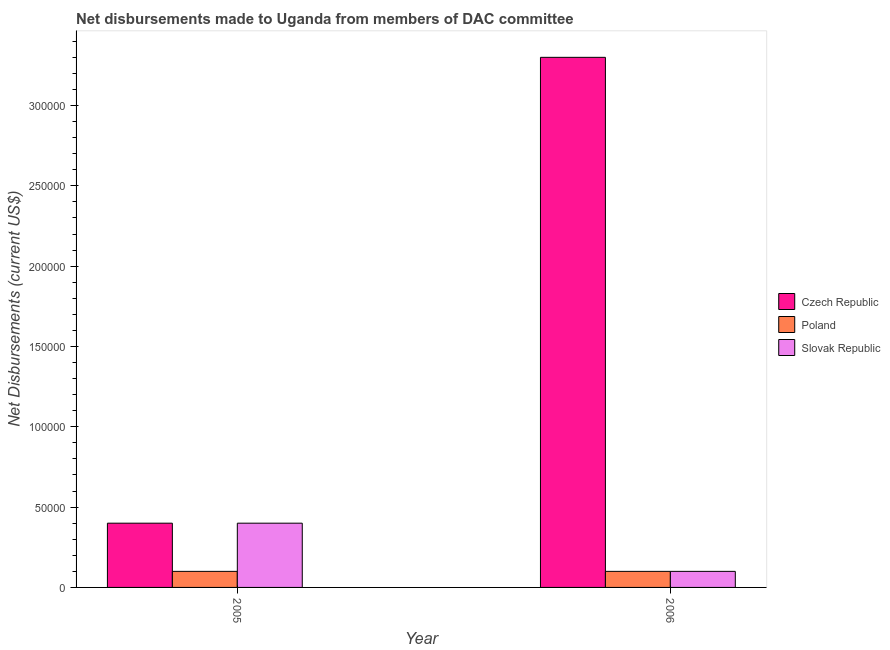How many groups of bars are there?
Ensure brevity in your answer.  2. Are the number of bars per tick equal to the number of legend labels?
Give a very brief answer. Yes. Are the number of bars on each tick of the X-axis equal?
Your answer should be very brief. Yes. How many bars are there on the 1st tick from the left?
Give a very brief answer. 3. What is the net disbursements made by poland in 2006?
Your answer should be compact. 10000. Across all years, what is the maximum net disbursements made by poland?
Your answer should be compact. 10000. Across all years, what is the minimum net disbursements made by slovak republic?
Your answer should be very brief. 10000. In which year was the net disbursements made by poland maximum?
Your response must be concise. 2005. In which year was the net disbursements made by czech republic minimum?
Your response must be concise. 2005. What is the total net disbursements made by czech republic in the graph?
Ensure brevity in your answer.  3.70e+05. What is the difference between the net disbursements made by czech republic in 2005 and that in 2006?
Your answer should be very brief. -2.90e+05. What is the difference between the net disbursements made by slovak republic in 2006 and the net disbursements made by czech republic in 2005?
Your response must be concise. -3.00e+04. What is the average net disbursements made by czech republic per year?
Your answer should be compact. 1.85e+05. What is the ratio of the net disbursements made by slovak republic in 2005 to that in 2006?
Keep it short and to the point. 4. Is the net disbursements made by slovak republic in 2005 less than that in 2006?
Your response must be concise. No. What does the 3rd bar from the left in 2006 represents?
Offer a terse response. Slovak Republic. What does the 1st bar from the right in 2005 represents?
Make the answer very short. Slovak Republic. Is it the case that in every year, the sum of the net disbursements made by czech republic and net disbursements made by poland is greater than the net disbursements made by slovak republic?
Offer a terse response. Yes. How many bars are there?
Offer a very short reply. 6. Are all the bars in the graph horizontal?
Provide a succinct answer. No. What is the difference between two consecutive major ticks on the Y-axis?
Your answer should be compact. 5.00e+04. Does the graph contain any zero values?
Your answer should be compact. No. Where does the legend appear in the graph?
Ensure brevity in your answer.  Center right. How many legend labels are there?
Ensure brevity in your answer.  3. What is the title of the graph?
Keep it short and to the point. Net disbursements made to Uganda from members of DAC committee. Does "Hydroelectric sources" appear as one of the legend labels in the graph?
Give a very brief answer. No. What is the label or title of the X-axis?
Provide a short and direct response. Year. What is the label or title of the Y-axis?
Make the answer very short. Net Disbursements (current US$). What is the Net Disbursements (current US$) in Czech Republic in 2005?
Provide a succinct answer. 4.00e+04. What is the Net Disbursements (current US$) of Poland in 2005?
Offer a terse response. 10000. What is the Net Disbursements (current US$) in Slovak Republic in 2006?
Your answer should be very brief. 10000. Across all years, what is the maximum Net Disbursements (current US$) of Poland?
Provide a succinct answer. 10000. Across all years, what is the minimum Net Disbursements (current US$) of Czech Republic?
Ensure brevity in your answer.  4.00e+04. Across all years, what is the minimum Net Disbursements (current US$) of Poland?
Offer a very short reply. 10000. Across all years, what is the minimum Net Disbursements (current US$) of Slovak Republic?
Your answer should be very brief. 10000. What is the total Net Disbursements (current US$) of Poland in the graph?
Your answer should be compact. 2.00e+04. What is the total Net Disbursements (current US$) in Slovak Republic in the graph?
Your answer should be very brief. 5.00e+04. What is the difference between the Net Disbursements (current US$) of Czech Republic in 2005 and that in 2006?
Provide a short and direct response. -2.90e+05. What is the difference between the Net Disbursements (current US$) of Czech Republic in 2005 and the Net Disbursements (current US$) of Poland in 2006?
Your answer should be very brief. 3.00e+04. What is the average Net Disbursements (current US$) in Czech Republic per year?
Offer a terse response. 1.85e+05. What is the average Net Disbursements (current US$) in Slovak Republic per year?
Make the answer very short. 2.50e+04. In the year 2005, what is the difference between the Net Disbursements (current US$) in Czech Republic and Net Disbursements (current US$) in Poland?
Make the answer very short. 3.00e+04. In the year 2005, what is the difference between the Net Disbursements (current US$) of Czech Republic and Net Disbursements (current US$) of Slovak Republic?
Your answer should be compact. 0. What is the ratio of the Net Disbursements (current US$) of Czech Republic in 2005 to that in 2006?
Offer a terse response. 0.12. What is the difference between the highest and the second highest Net Disbursements (current US$) in Czech Republic?
Provide a succinct answer. 2.90e+05. What is the difference between the highest and the second highest Net Disbursements (current US$) of Slovak Republic?
Offer a very short reply. 3.00e+04. What is the difference between the highest and the lowest Net Disbursements (current US$) in Czech Republic?
Provide a short and direct response. 2.90e+05. 